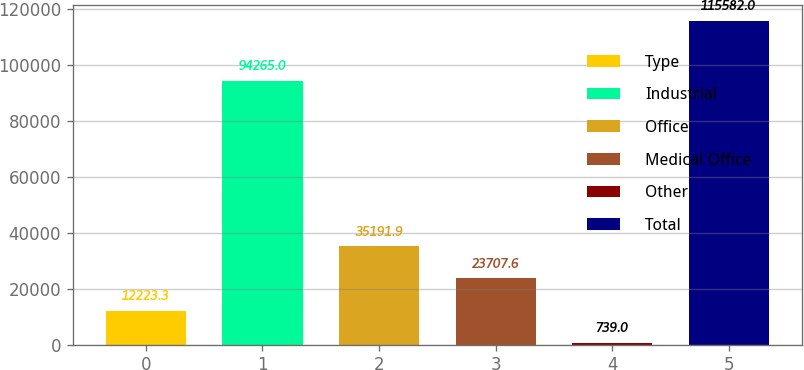Convert chart to OTSL. <chart><loc_0><loc_0><loc_500><loc_500><bar_chart><fcel>Type<fcel>Industrial<fcel>Office<fcel>Medical Office<fcel>Other<fcel>Total<nl><fcel>12223.3<fcel>94265<fcel>35191.9<fcel>23707.6<fcel>739<fcel>115582<nl></chart> 